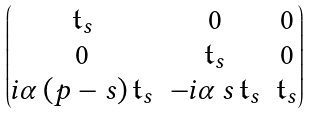Convert formula to latex. <formula><loc_0><loc_0><loc_500><loc_500>\begin{pmatrix} \mathfrak { t } _ { s } & 0 & 0 \\ 0 & \mathfrak { t } _ { s } & 0 \\ i \alpha \, ( p - s ) \, \mathfrak { t } _ { s } & - i \alpha \, s \, \mathfrak { t } _ { s } & \mathfrak { t } _ { s } \end{pmatrix}</formula> 